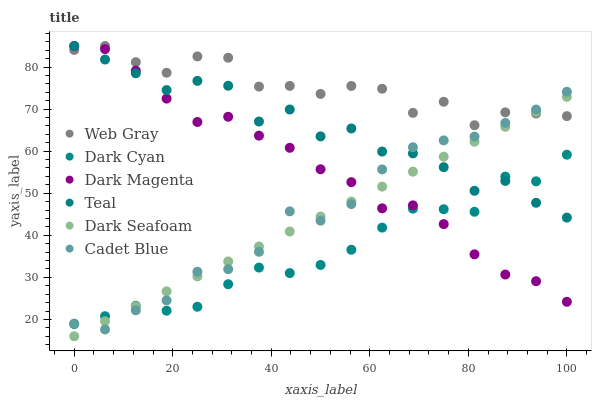Does Dark Cyan have the minimum area under the curve?
Answer yes or no. Yes. Does Web Gray have the maximum area under the curve?
Answer yes or no. Yes. Does Dark Magenta have the minimum area under the curve?
Answer yes or no. No. Does Dark Magenta have the maximum area under the curve?
Answer yes or no. No. Is Dark Seafoam the smoothest?
Answer yes or no. Yes. Is Teal the roughest?
Answer yes or no. Yes. Is Dark Magenta the smoothest?
Answer yes or no. No. Is Dark Magenta the roughest?
Answer yes or no. No. Does Dark Seafoam have the lowest value?
Answer yes or no. Yes. Does Dark Magenta have the lowest value?
Answer yes or no. No. Does Teal have the highest value?
Answer yes or no. Yes. Does Dark Seafoam have the highest value?
Answer yes or no. No. Is Dark Cyan less than Web Gray?
Answer yes or no. Yes. Is Web Gray greater than Dark Cyan?
Answer yes or no. Yes. Does Cadet Blue intersect Teal?
Answer yes or no. Yes. Is Cadet Blue less than Teal?
Answer yes or no. No. Is Cadet Blue greater than Teal?
Answer yes or no. No. Does Dark Cyan intersect Web Gray?
Answer yes or no. No. 